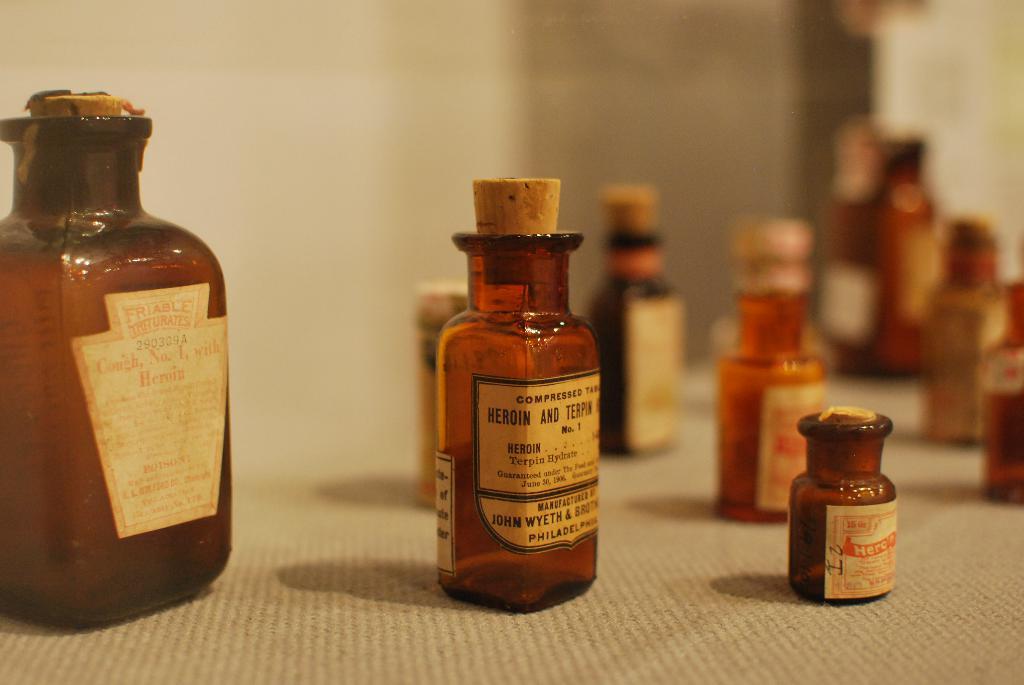Is that a bottle of heroin?
Make the answer very short. Yes. Where was the bottle in the middle manufactured?
Your answer should be very brief. Philadelphia. 